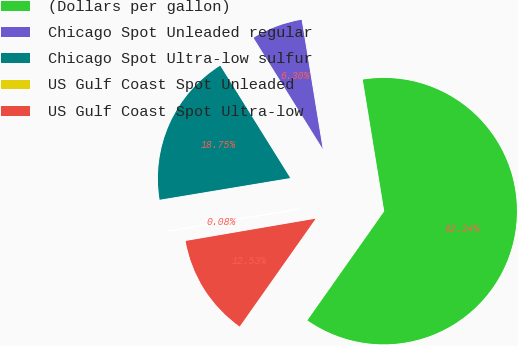Convert chart. <chart><loc_0><loc_0><loc_500><loc_500><pie_chart><fcel>(Dollars per gallon)<fcel>Chicago Spot Unleaded regular<fcel>Chicago Spot Ultra-low sulfur<fcel>US Gulf Coast Spot Unleaded<fcel>US Gulf Coast Spot Ultra-low<nl><fcel>62.34%<fcel>6.3%<fcel>18.75%<fcel>0.08%<fcel>12.53%<nl></chart> 